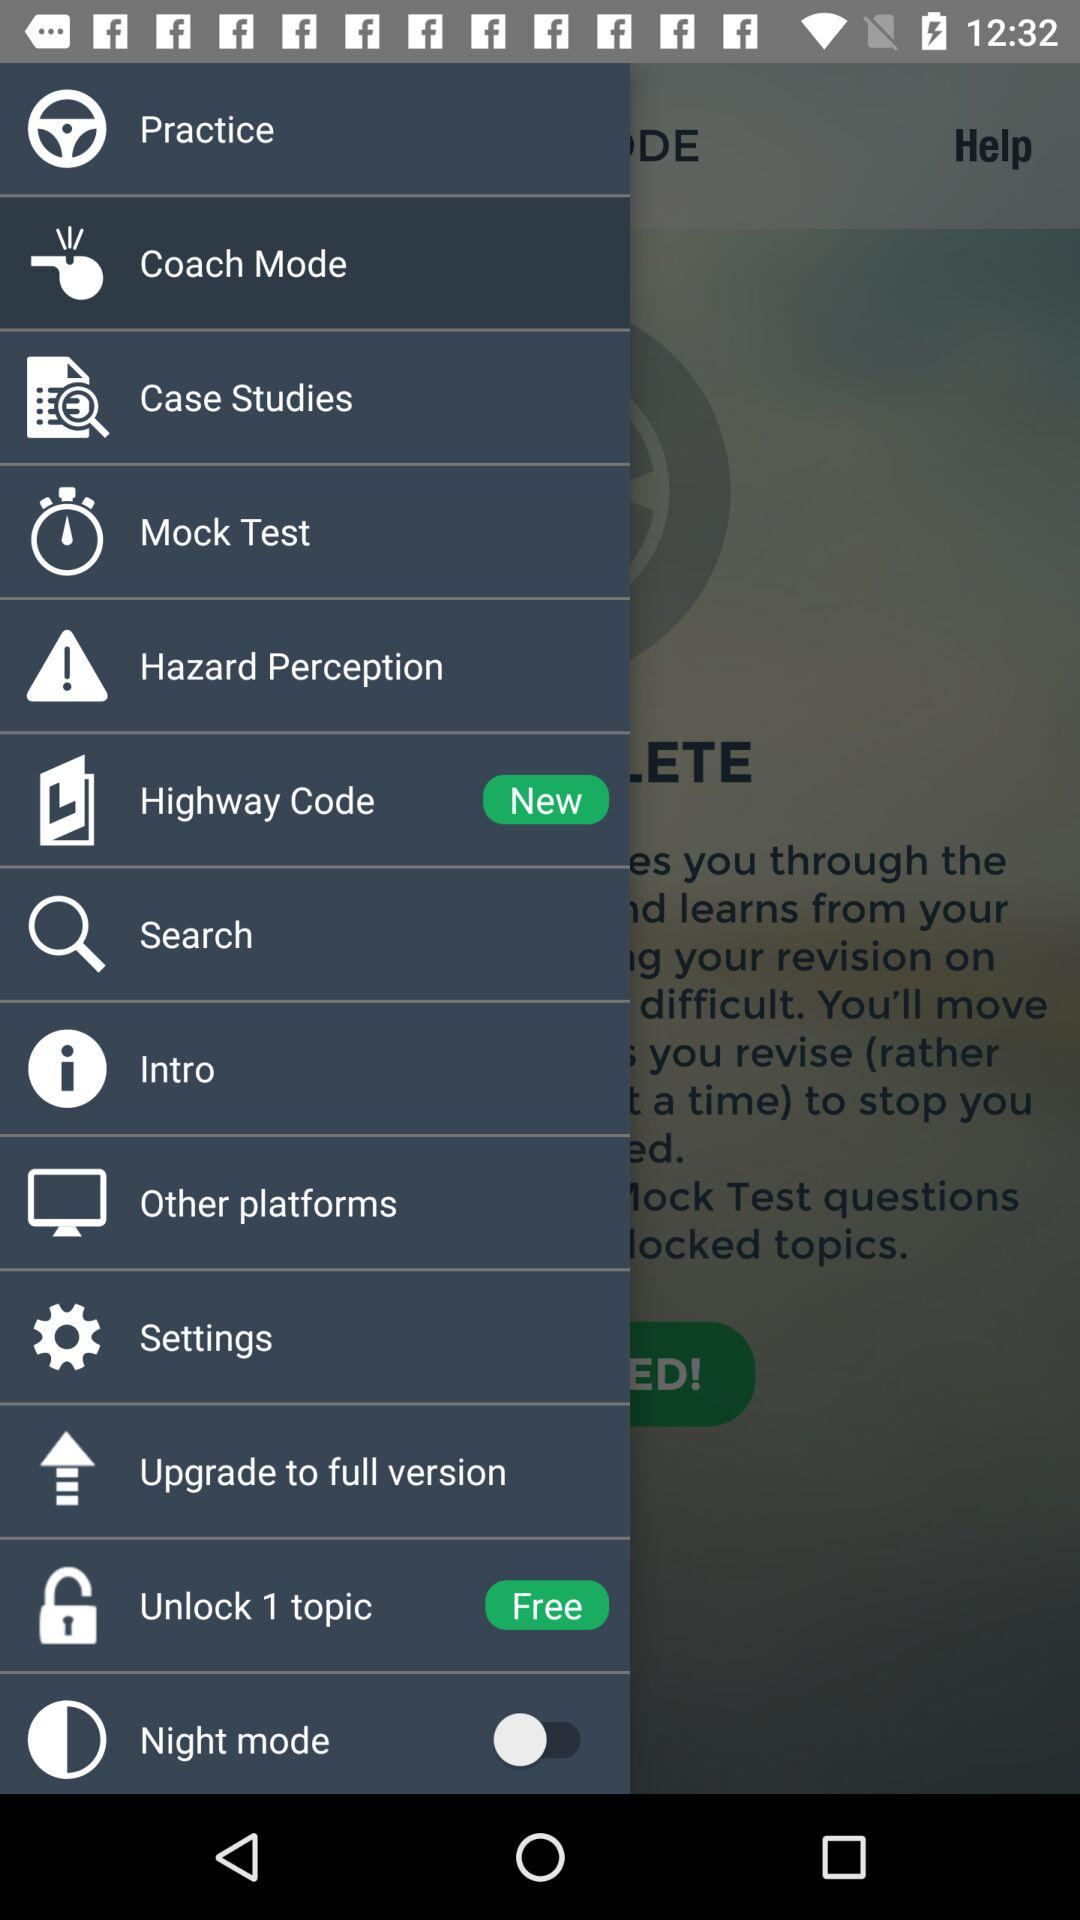Is "Unlock 1 topic" free or paid?
Answer the question using a single word or phrase. It is free. 